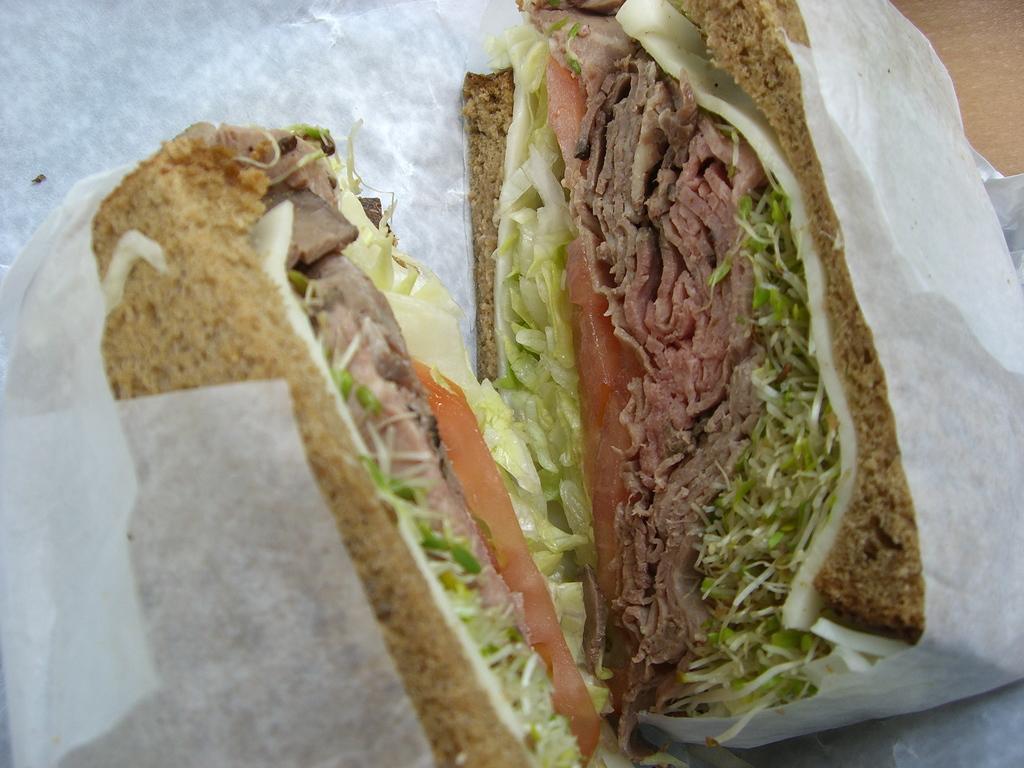Please provide a concise description of this image. Here I can see a food item which is packed with a white color paper. 